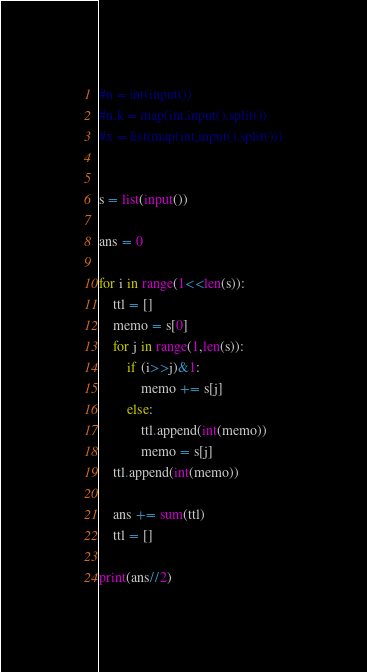Convert code to text. <code><loc_0><loc_0><loc_500><loc_500><_Python_>#n = int(input())
#n,k = map(int,input().split())
#x = list(map(int,input().split()))


s = list(input())

ans = 0

for i in range(1<<len(s)):
    ttl = []
    memo = s[0]
    for j in range(1,len(s)):
        if (i>>j)&1:
            memo += s[j]
        else:
            ttl.append(int(memo))
            memo = s[j]
    ttl.append(int(memo))
    
    ans += sum(ttl)
    ttl = []

print(ans//2)


</code> 